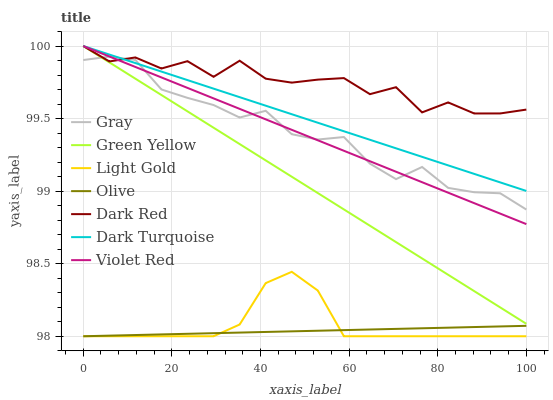Does Violet Red have the minimum area under the curve?
Answer yes or no. No. Does Violet Red have the maximum area under the curve?
Answer yes or no. No. Is Violet Red the smoothest?
Answer yes or no. No. Is Violet Red the roughest?
Answer yes or no. No. Does Violet Red have the lowest value?
Answer yes or no. No. Does Olive have the highest value?
Answer yes or no. No. Is Olive less than Violet Red?
Answer yes or no. Yes. Is Gray greater than Olive?
Answer yes or no. Yes. Does Olive intersect Violet Red?
Answer yes or no. No. 